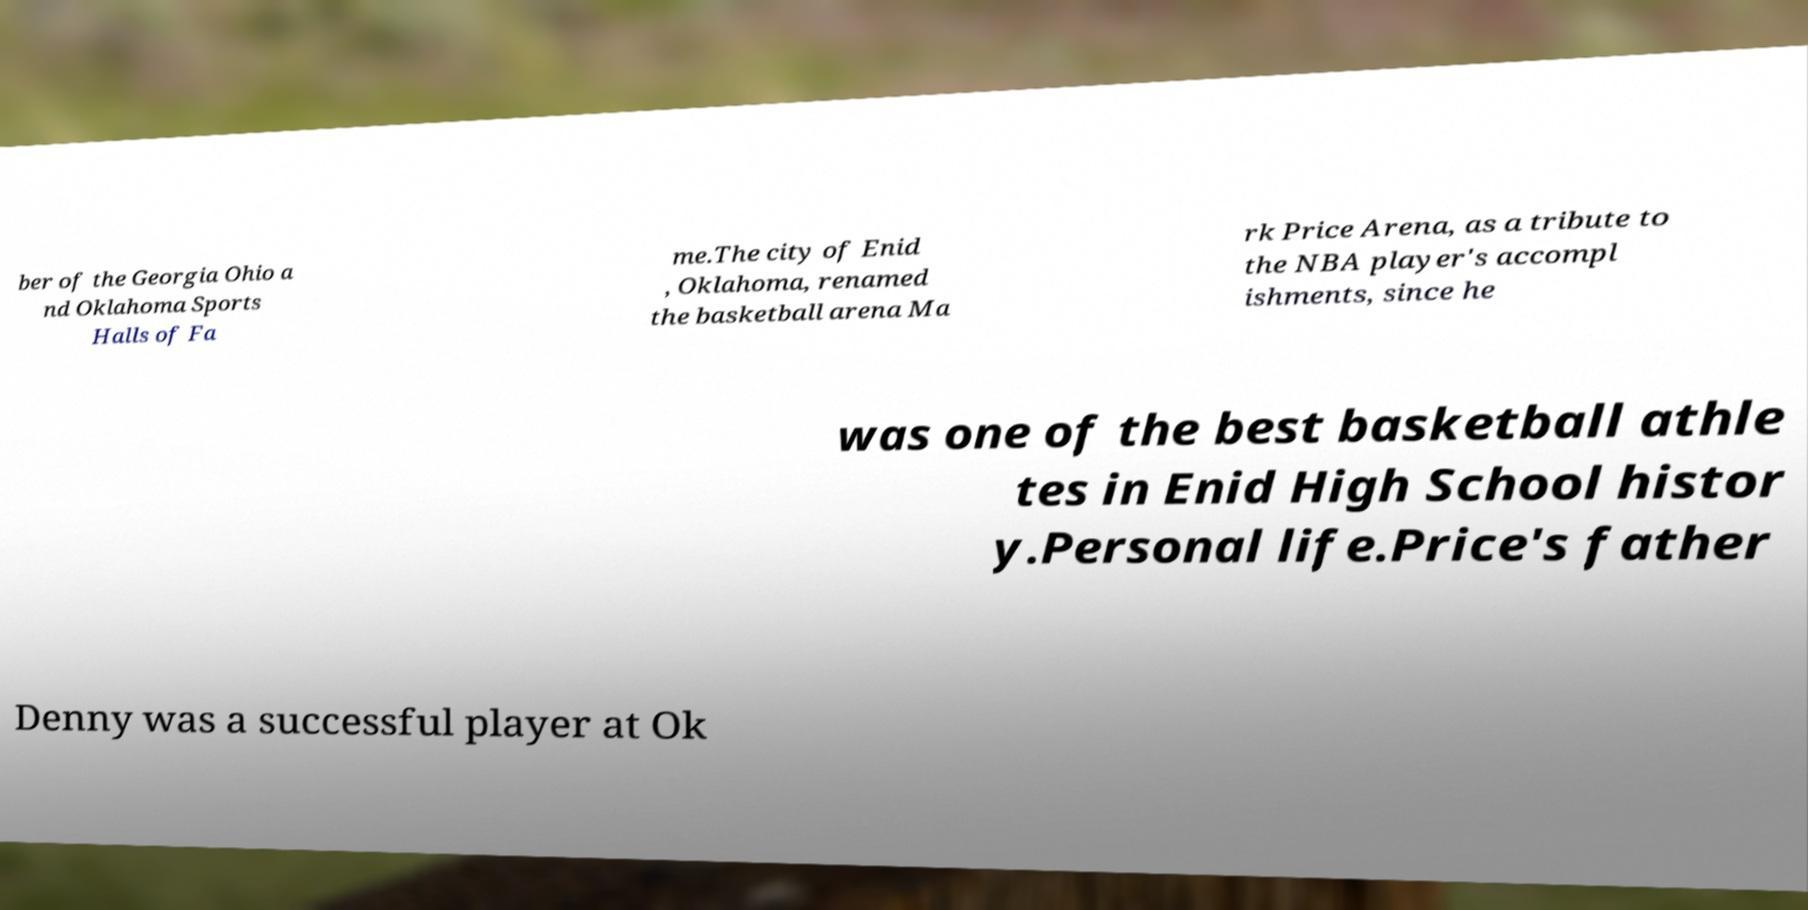There's text embedded in this image that I need extracted. Can you transcribe it verbatim? ber of the Georgia Ohio a nd Oklahoma Sports Halls of Fa me.The city of Enid , Oklahoma, renamed the basketball arena Ma rk Price Arena, as a tribute to the NBA player's accompl ishments, since he was one of the best basketball athle tes in Enid High School histor y.Personal life.Price's father Denny was a successful player at Ok 